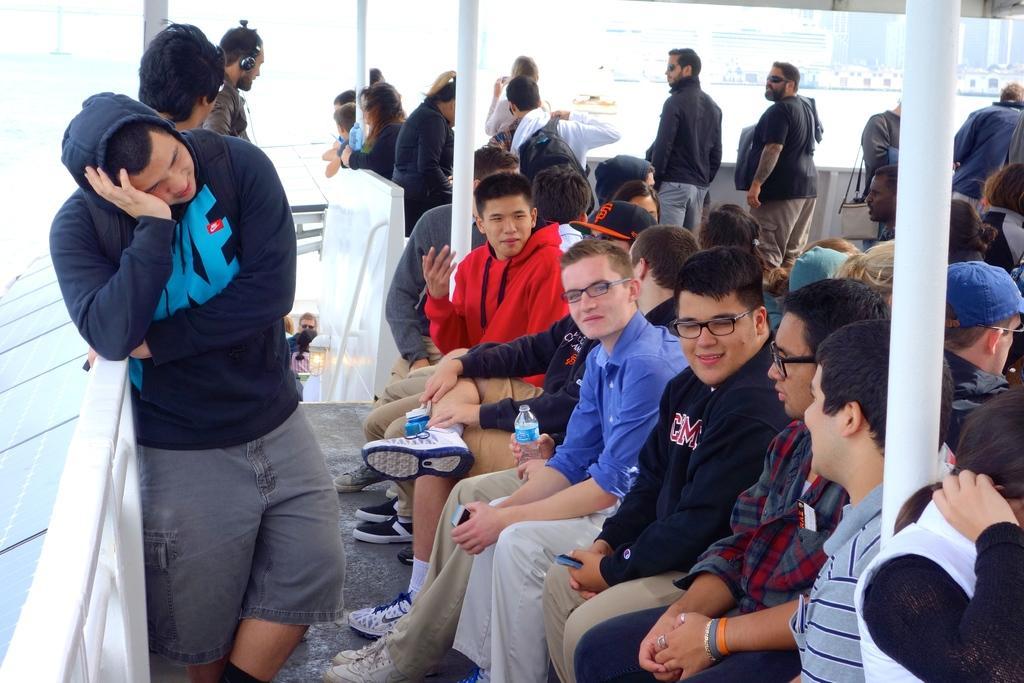Can you describe this image briefly? I think this picture is taken outside. There are group of people sitting and standing. Towards the left there is a person wearing blue sweater, grey shorts and leaning to a hand grill. Towards the right there is a woman, she is wearing a white dress. There are three poles in the middle. 